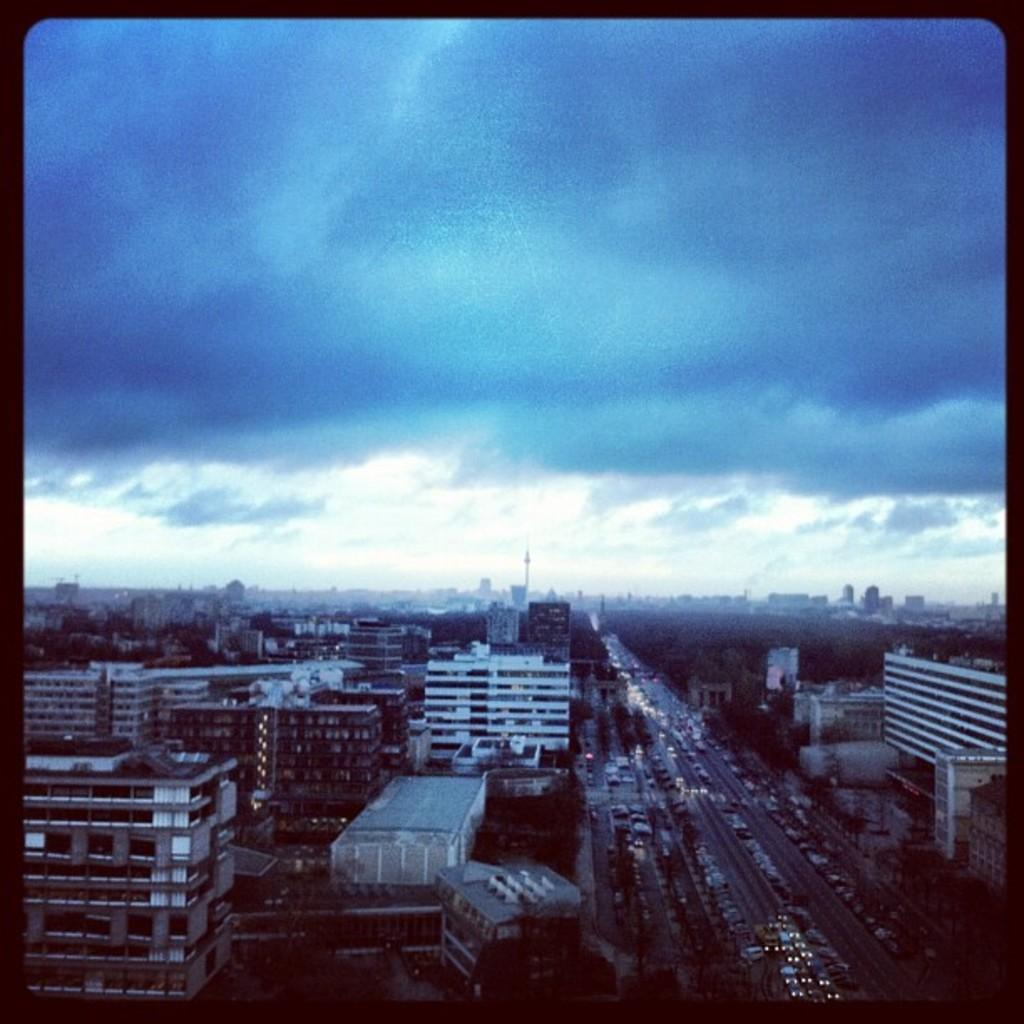What type of structures can be seen in the image? There are many buildings in the image. What is located at the bottom of the image? There is a road at the bottom of the image. What is moving along the road in the image? There are vehicles on the road. What can be seen in the sky at the top of the image? There are clouds in the sky at the top of the image. Where is the mine located in the image? There is no mine present in the image. On which side of the road are the buildings located? The provided facts do not specify the side of the road where the buildings are located. 